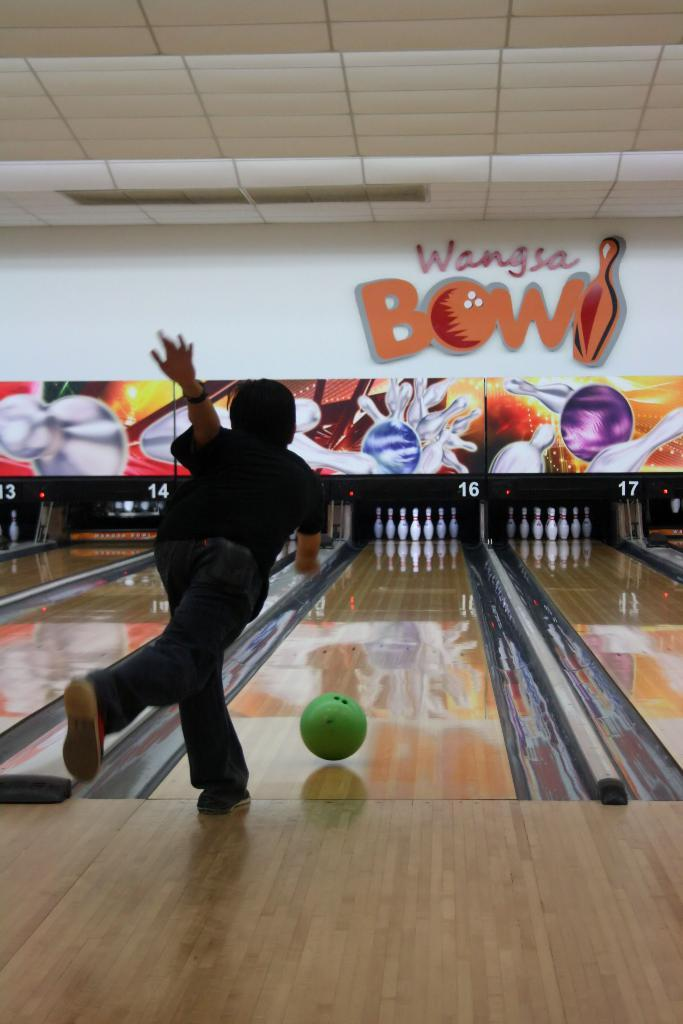What activity is the person in the image engaged in? The person is playing bowling in the image. What surface is the person standing on while playing bowling? There is a floor in the image. What object is the person using to knock down the pins? There is a ball in the image. What objects are the person aiming to knock down with the ball? There are bowling pins in the image. What type of advertisements or signs can be seen in the background? There are hoardings in the image. What is above the person while playing bowling? There is a ceiling in the image. What can be seen written on the wall in the image? There is something written on the wall in the image. What type of field is visible in the image? There is no field visible in the image; it is a bowling alley. Whose birthday is being celebrated in the image? There is no indication of a birthday celebration in the image. 